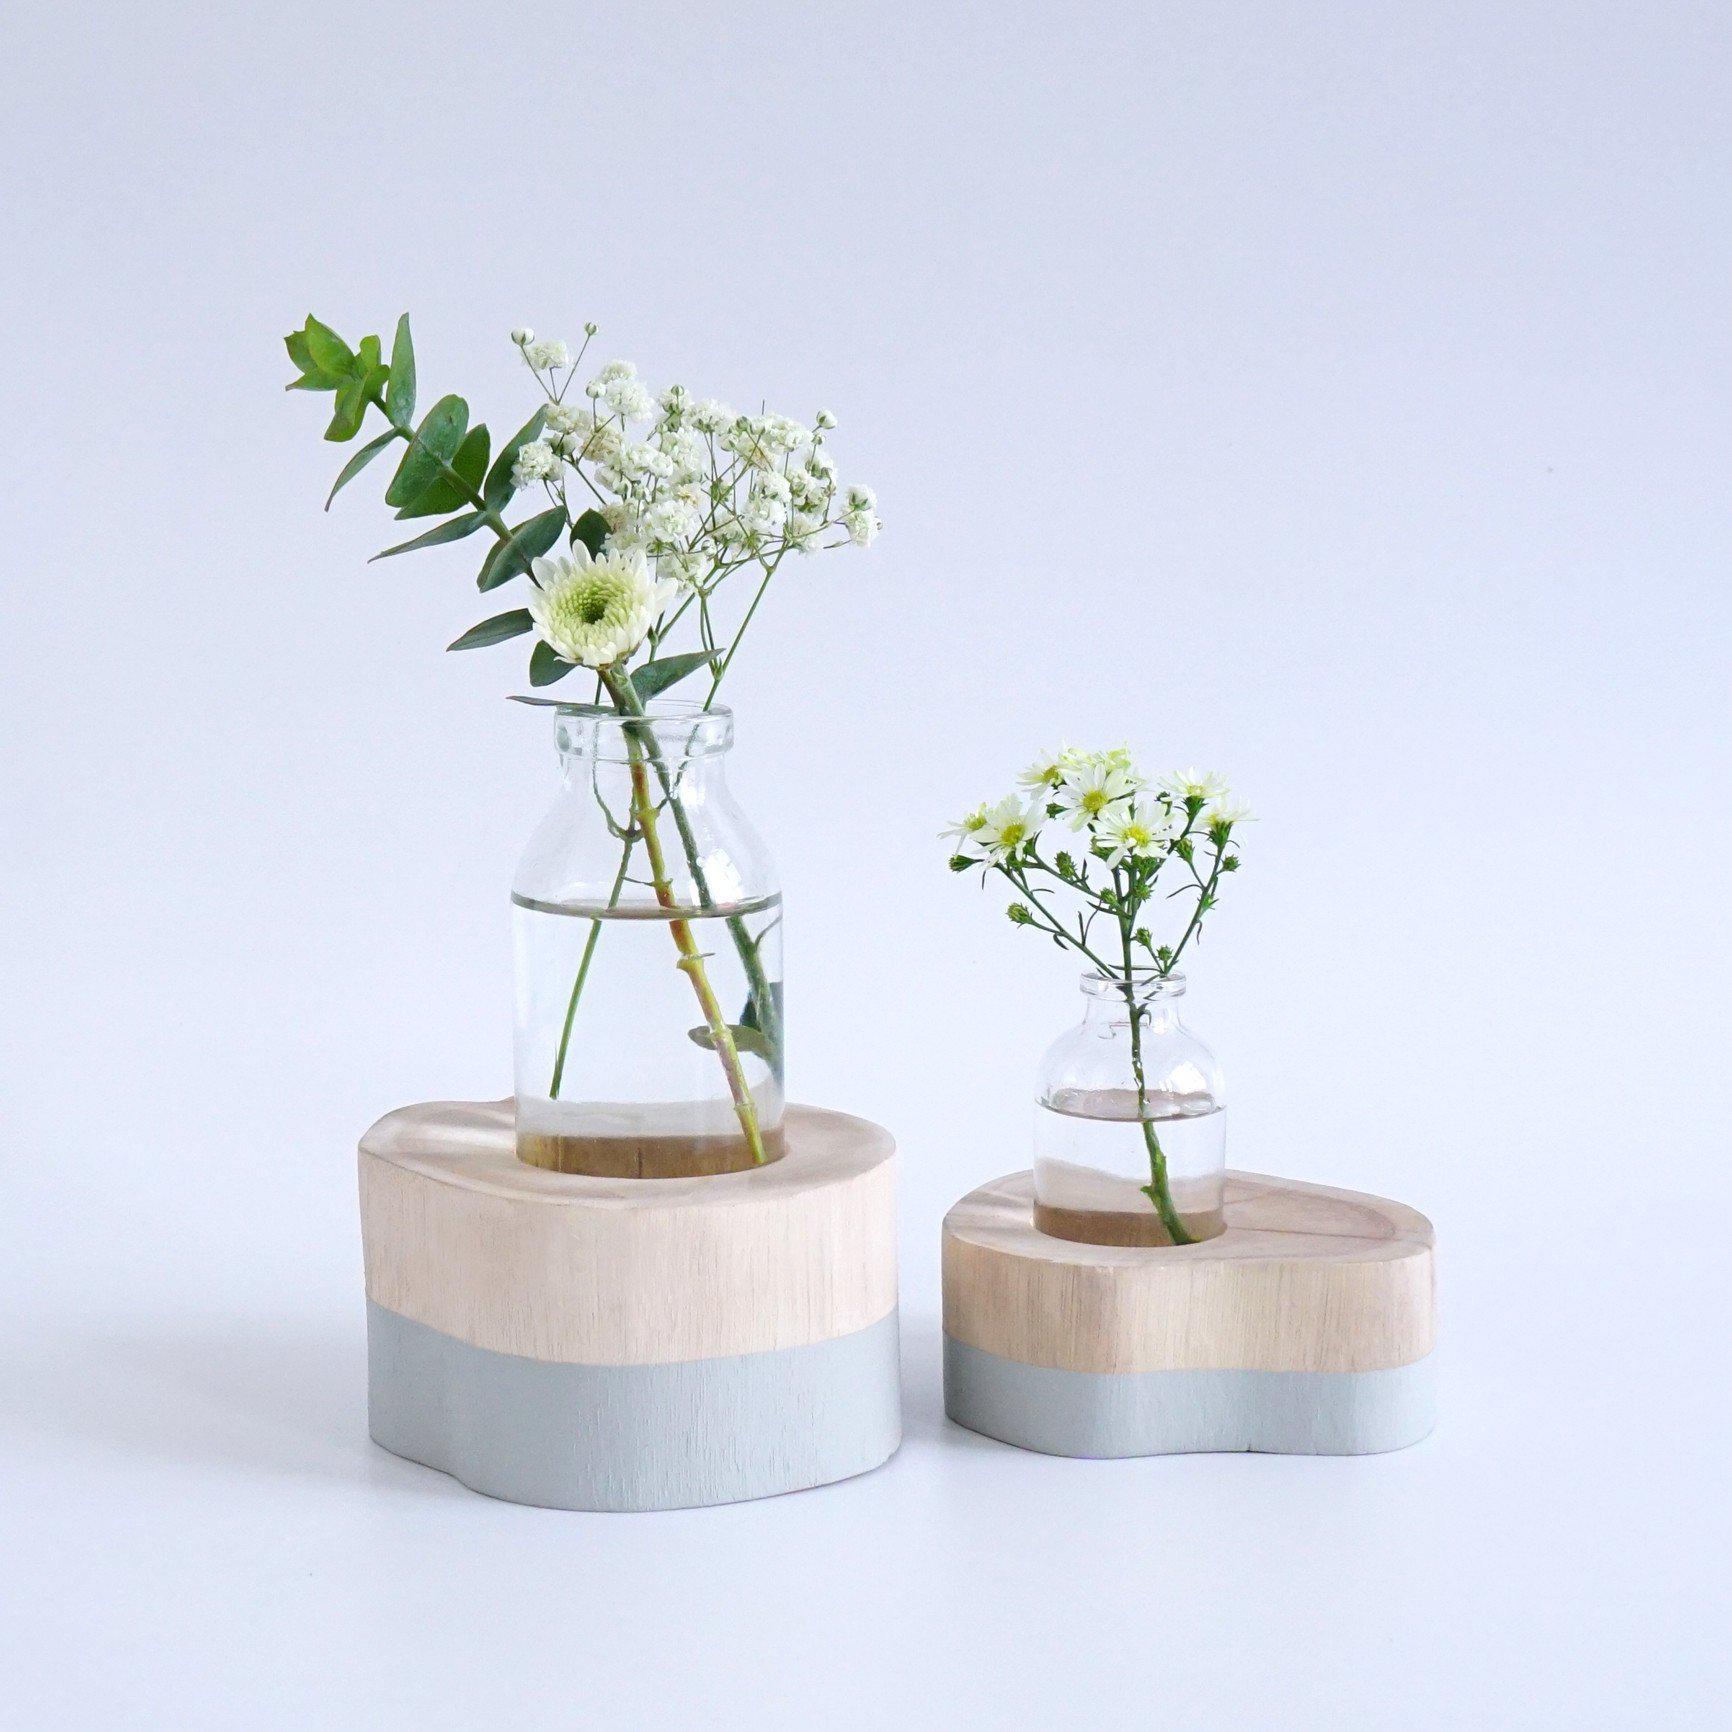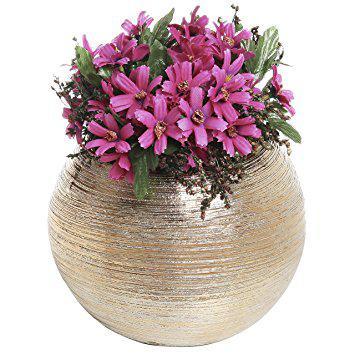The first image is the image on the left, the second image is the image on the right. For the images displayed, is the sentence "there are pink flowers in a vase" factually correct? Answer yes or no. Yes. The first image is the image on the left, the second image is the image on the right. Given the left and right images, does the statement "There are two round, clear vases with flowers in them" hold true? Answer yes or no. No. 